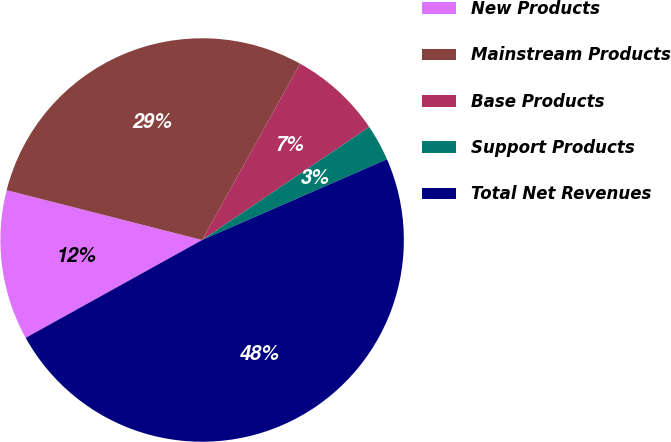<chart> <loc_0><loc_0><loc_500><loc_500><pie_chart><fcel>New Products<fcel>Mainstream Products<fcel>Base Products<fcel>Support Products<fcel>Total Net Revenues<nl><fcel>12.03%<fcel>29.1%<fcel>7.47%<fcel>2.91%<fcel>48.5%<nl></chart> 